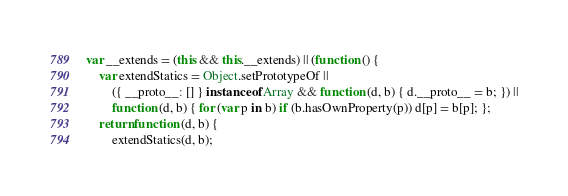<code> <loc_0><loc_0><loc_500><loc_500><_JavaScript_>var __extends = (this && this.__extends) || (function () {
    var extendStatics = Object.setPrototypeOf ||
        ({ __proto__: [] } instanceof Array && function (d, b) { d.__proto__ = b; }) ||
        function (d, b) { for (var p in b) if (b.hasOwnProperty(p)) d[p] = b[p]; };
    return function (d, b) {
        extendStatics(d, b);</code> 